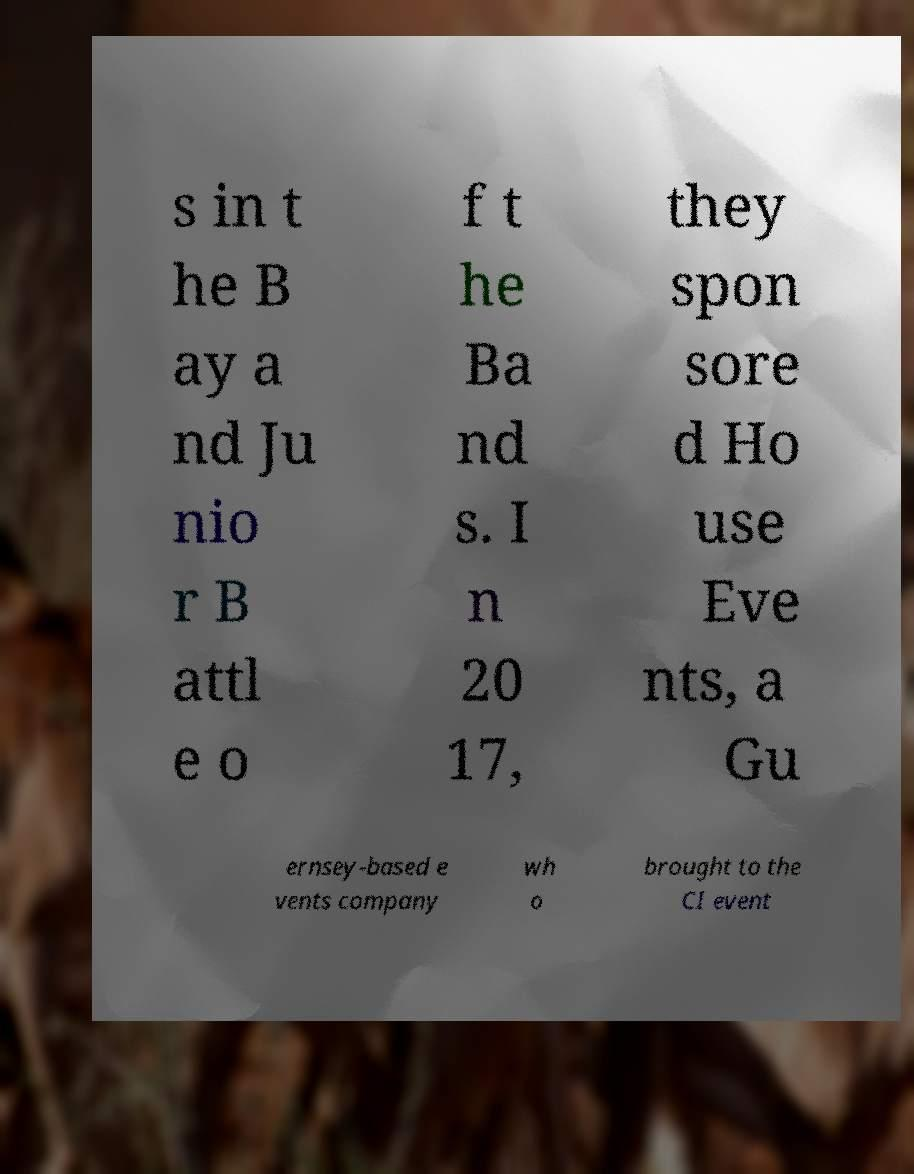Could you extract and type out the text from this image? s in t he B ay a nd Ju nio r B attl e o f t he Ba nd s. I n 20 17, they spon sore d Ho use Eve nts, a Gu ernsey-based e vents company wh o brought to the CI event 